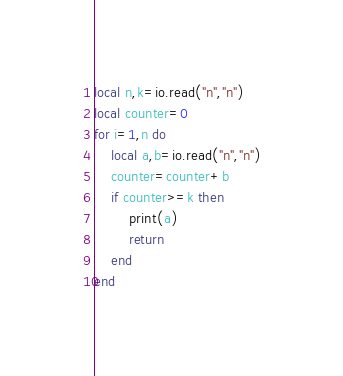Convert code to text. <code><loc_0><loc_0><loc_500><loc_500><_Lua_>local n,k=io.read("n","n")
local counter=0
for i=1,n do
    local a,b=io.read("n","n")
    counter=counter+b
    if counter>=k then
        print(a)
        return
    end
end</code> 